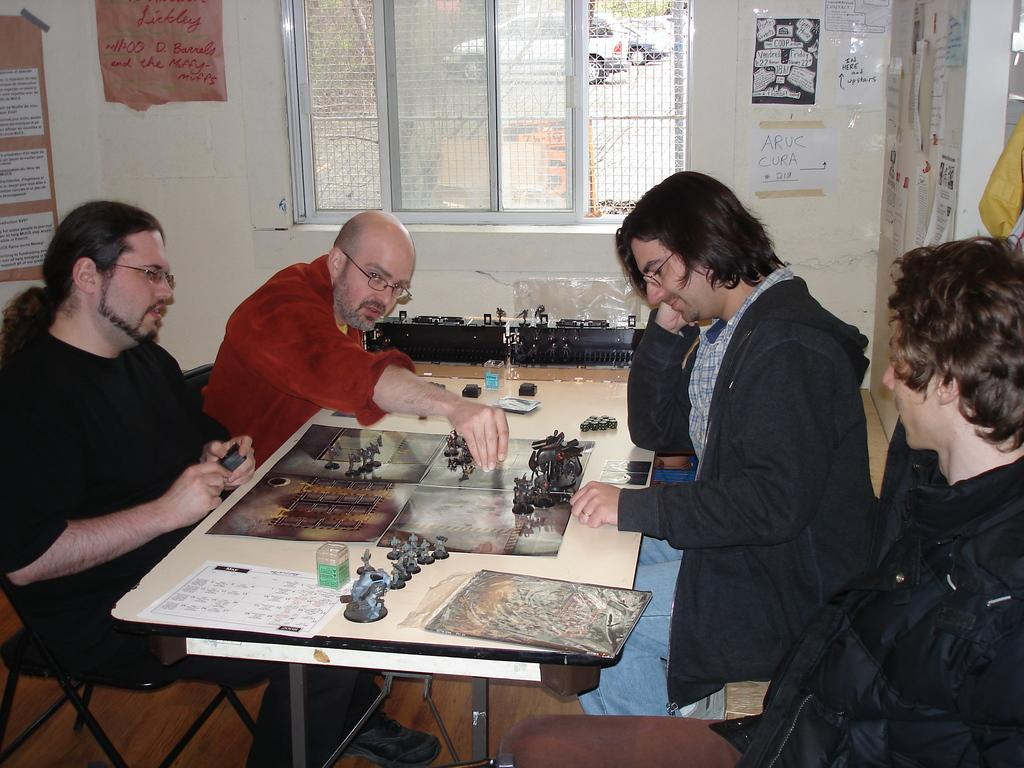How many people are in the image? There are four men in the image. What are the men doing in the image? The men are sitting around a table and playing a board game. What type of doctor is attending to the men in the image? There is no doctor present in the image; the men are playing a board game. What impulse might have led the men to start playing the board game in the image? The image does not provide information about the men's motivations or impulses for playing the board game. 